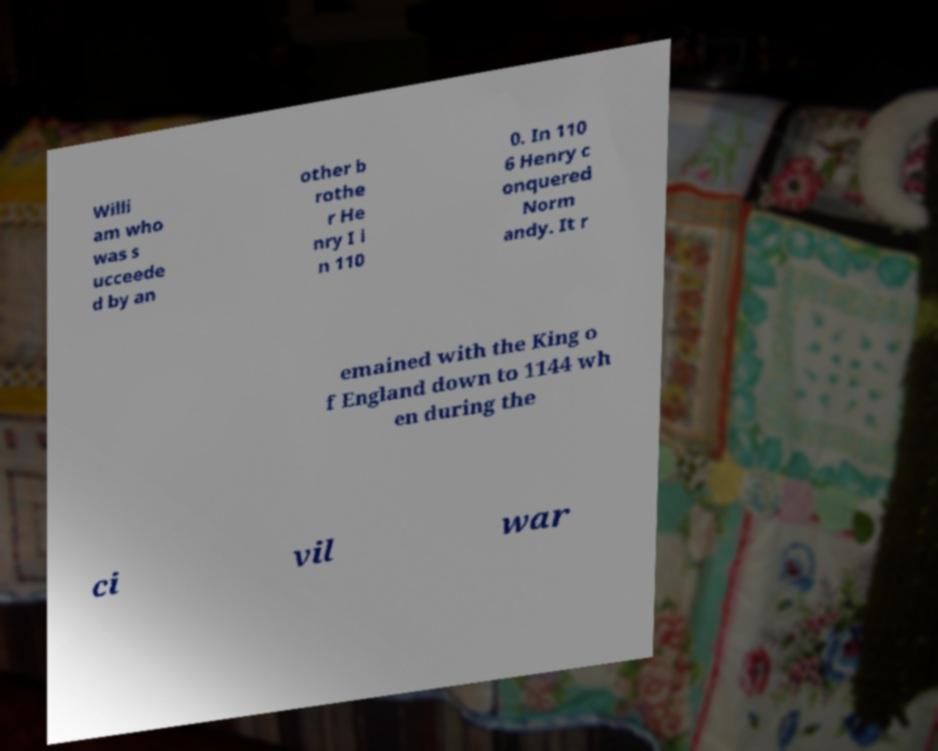Could you assist in decoding the text presented in this image and type it out clearly? Willi am who was s ucceede d by an other b rothe r He nry I i n 110 0. In 110 6 Henry c onquered Norm andy. It r emained with the King o f England down to 1144 wh en during the ci vil war 